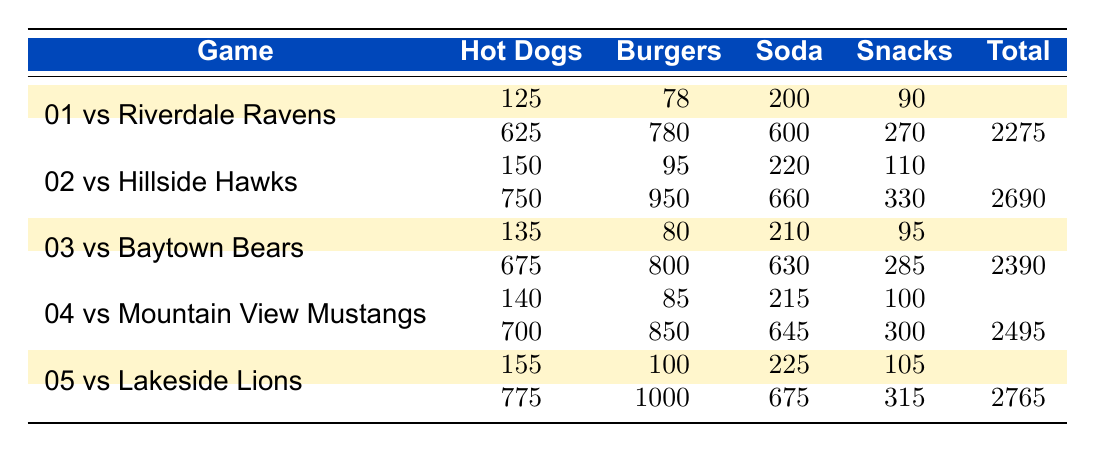What was the total revenue from hot dogs sold in the game against Riverdale Ravens? In the first game against the Riverdale Ravens, 125 hot dogs were sold, generating revenue of 625. Therefore, the total revenue from hot dogs is 625.
Answer: 625 Which game had the highest total revenue? By comparing the total revenue across all games, the highest value is in the game against Lakeside Lions, where the total revenue is 2765.
Answer: 2765 How many more burgers were sold in the game against Hillside Hawks compared to the game against Riverdale Ravens? In the game against Hillside Hawks, 95 burgers were sold, and against Riverdale Ravens, 78 burgers were sold. The difference is 95 - 78 = 17 more burgers sold in the Hillside Hawks game.
Answer: 17 What is the average total revenue per game? The total revenues for each game are 2275, 2690, 2390, 2495, and 2765. Summing these values gives 12715. Dividing by the number of games, which is 5, results in an average total revenue of 12715 / 5 = 2543.
Answer: 2543 Did the Clay Panthers earn more than 2500 in total revenue against any opponent? Reviewing the total revenues, the games against Hillside Hawks, Mountain View Mustangs, and Lakeside Lions all exceeded 2500 in revenue. Therefore, the statement is true.
Answer: Yes In which game was the revenue from snacks the highest? The revenue from snacks in each game is 270, 330, 285, 300, and 315. The highest revenue from snacks is in the game against Lakeside Lions, earning 315.
Answer: Lakeside Lions What is the total revenue from soda sold in all games? The soda revenues from each game are 600, 660, 630, 645, and 675. Summing these gives a total revenue from soda of 600 + 660 + 630 + 645 + 675 = 3210.
Answer: 3210 Did the number of hot dogs sold increase in every game? Comparing the number of hot dogs sold: 125, 150, 135, 140, and 155. From the second to the third game, there was a decrease (150 to 135). Thus, the statement is false.
Answer: No How much was earned from snacks in the game against Baytown Bears? The revenue earned from snacks in the game against the Baytown Bears is noted as 285.
Answer: 285 